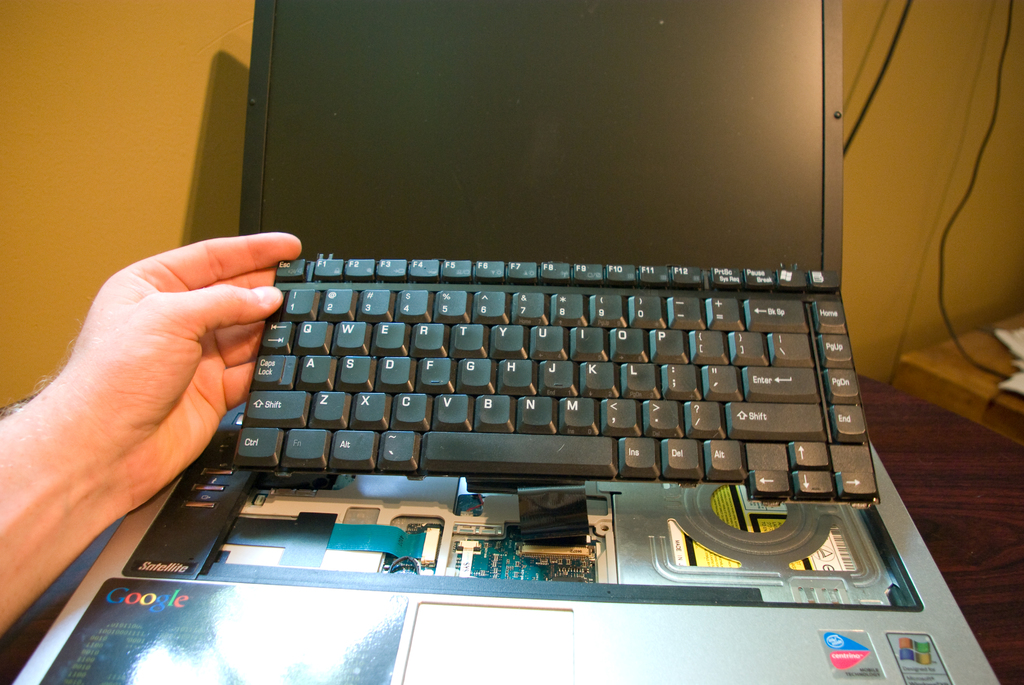Provide a one-sentence caption for the provided image. A partially disassembled laptop displays its internal hardware and keyboard, prominently featuring the Google logo on the wrist rest. 